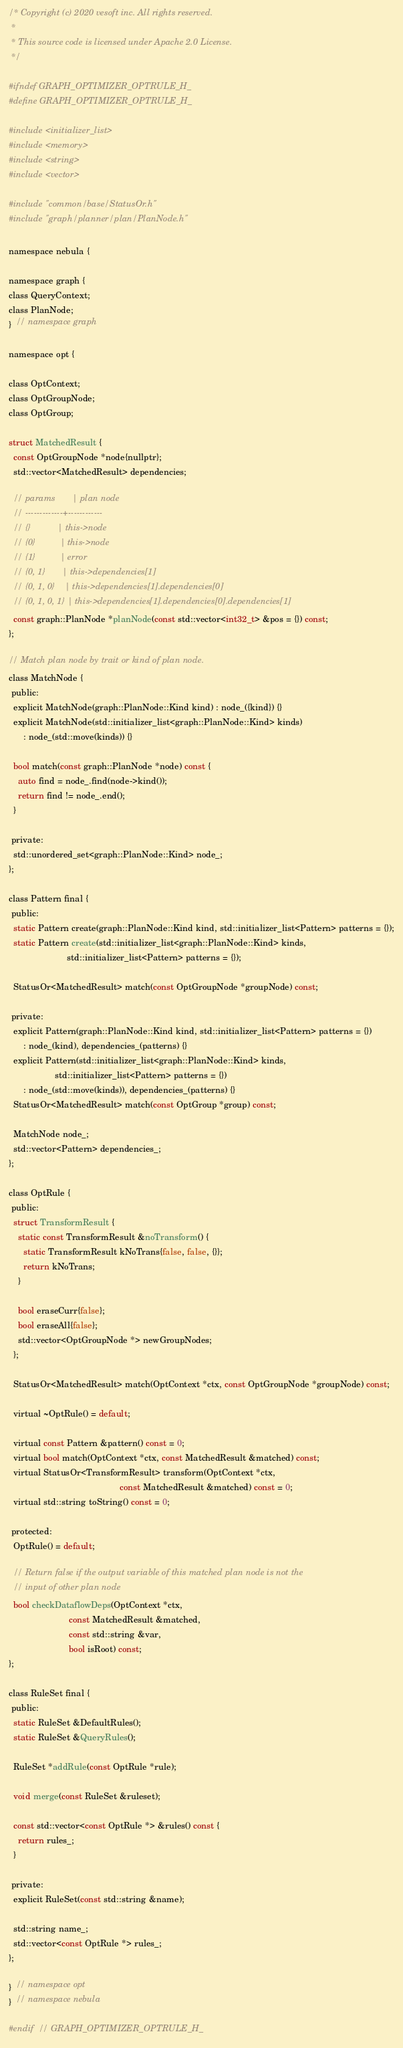Convert code to text. <code><loc_0><loc_0><loc_500><loc_500><_C_>/* Copyright (c) 2020 vesoft inc. All rights reserved.
 *
 * This source code is licensed under Apache 2.0 License.
 */

#ifndef GRAPH_OPTIMIZER_OPTRULE_H_
#define GRAPH_OPTIMIZER_OPTRULE_H_

#include <initializer_list>
#include <memory>
#include <string>
#include <vector>

#include "common/base/StatusOr.h"
#include "graph/planner/plan/PlanNode.h"

namespace nebula {

namespace graph {
class QueryContext;
class PlanNode;
}  // namespace graph

namespace opt {

class OptContext;
class OptGroupNode;
class OptGroup;

struct MatchedResult {
  const OptGroupNode *node{nullptr};
  std::vector<MatchedResult> dependencies;

  // params       | plan node
  // -------------+------------
  // {}           | this->node
  // {0}          | this->node
  // {1}          | error
  // {0, 1}       | this->dependencies[1]
  // {0, 1, 0}    | this->dependencies[1].dependencies[0]
  // {0, 1, 0, 1} | this->dependencies[1].dependencies[0].dependencies[1]
  const graph::PlanNode *planNode(const std::vector<int32_t> &pos = {}) const;
};

// Match plan node by trait or kind of plan node.
class MatchNode {
 public:
  explicit MatchNode(graph::PlanNode::Kind kind) : node_({kind}) {}
  explicit MatchNode(std::initializer_list<graph::PlanNode::Kind> kinds)
      : node_(std::move(kinds)) {}

  bool match(const graph::PlanNode *node) const {
    auto find = node_.find(node->kind());
    return find != node_.end();
  }

 private:
  std::unordered_set<graph::PlanNode::Kind> node_;
};

class Pattern final {
 public:
  static Pattern create(graph::PlanNode::Kind kind, std::initializer_list<Pattern> patterns = {});
  static Pattern create(std::initializer_list<graph::PlanNode::Kind> kinds,
                        std::initializer_list<Pattern> patterns = {});

  StatusOr<MatchedResult> match(const OptGroupNode *groupNode) const;

 private:
  explicit Pattern(graph::PlanNode::Kind kind, std::initializer_list<Pattern> patterns = {})
      : node_(kind), dependencies_(patterns) {}
  explicit Pattern(std::initializer_list<graph::PlanNode::Kind> kinds,
                   std::initializer_list<Pattern> patterns = {})
      : node_(std::move(kinds)), dependencies_(patterns) {}
  StatusOr<MatchedResult> match(const OptGroup *group) const;

  MatchNode node_;
  std::vector<Pattern> dependencies_;
};

class OptRule {
 public:
  struct TransformResult {
    static const TransformResult &noTransform() {
      static TransformResult kNoTrans{false, false, {}};
      return kNoTrans;
    }

    bool eraseCurr{false};
    bool eraseAll{false};
    std::vector<OptGroupNode *> newGroupNodes;
  };

  StatusOr<MatchedResult> match(OptContext *ctx, const OptGroupNode *groupNode) const;

  virtual ~OptRule() = default;

  virtual const Pattern &pattern() const = 0;
  virtual bool match(OptContext *ctx, const MatchedResult &matched) const;
  virtual StatusOr<TransformResult> transform(OptContext *ctx,
                                              const MatchedResult &matched) const = 0;
  virtual std::string toString() const = 0;

 protected:
  OptRule() = default;

  // Return false if the output variable of this matched plan node is not the
  // input of other plan node
  bool checkDataflowDeps(OptContext *ctx,
                         const MatchedResult &matched,
                         const std::string &var,
                         bool isRoot) const;
};

class RuleSet final {
 public:
  static RuleSet &DefaultRules();
  static RuleSet &QueryRules();

  RuleSet *addRule(const OptRule *rule);

  void merge(const RuleSet &ruleset);

  const std::vector<const OptRule *> &rules() const {
    return rules_;
  }

 private:
  explicit RuleSet(const std::string &name);

  std::string name_;
  std::vector<const OptRule *> rules_;
};

}  // namespace opt
}  // namespace nebula

#endif  // GRAPH_OPTIMIZER_OPTRULE_H_
</code> 